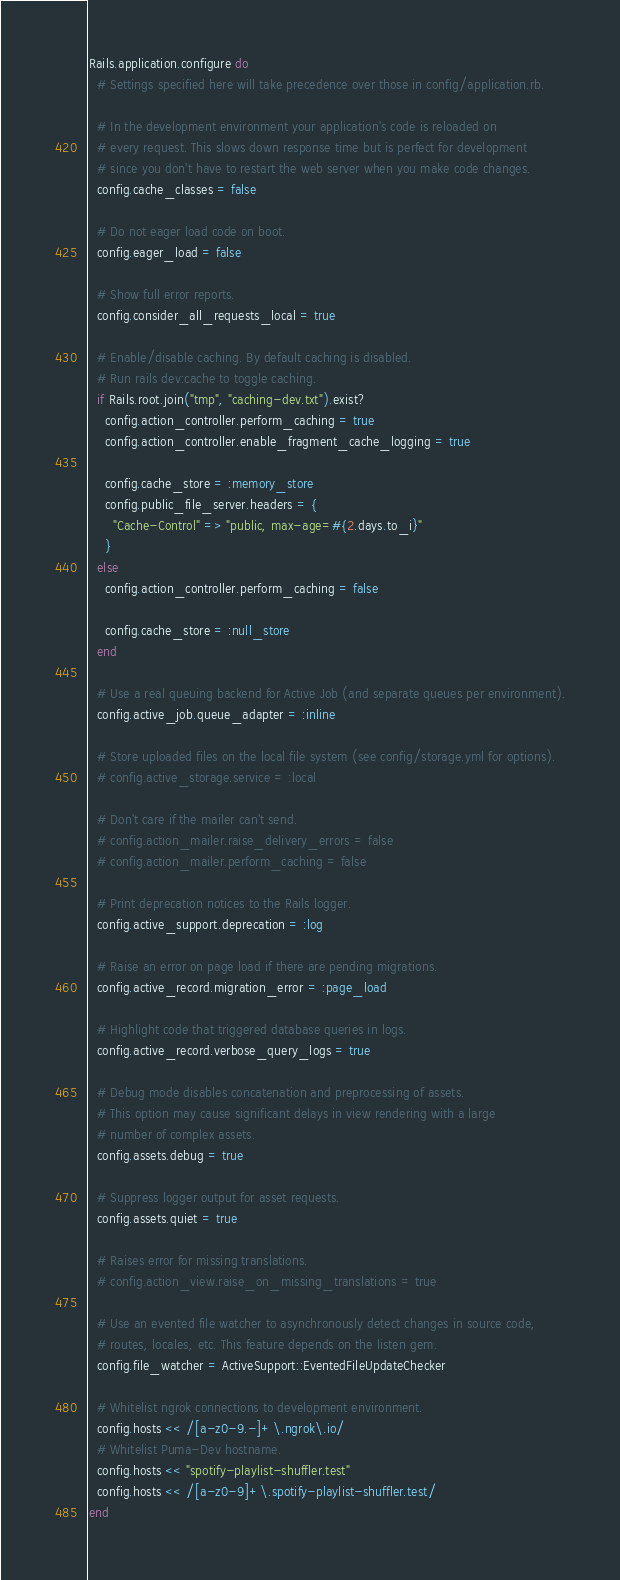<code> <loc_0><loc_0><loc_500><loc_500><_Ruby_>Rails.application.configure do
  # Settings specified here will take precedence over those in config/application.rb.

  # In the development environment your application's code is reloaded on
  # every request. This slows down response time but is perfect for development
  # since you don't have to restart the web server when you make code changes.
  config.cache_classes = false

  # Do not eager load code on boot.
  config.eager_load = false

  # Show full error reports.
  config.consider_all_requests_local = true

  # Enable/disable caching. By default caching is disabled.
  # Run rails dev:cache to toggle caching.
  if Rails.root.join("tmp", "caching-dev.txt").exist?
    config.action_controller.perform_caching = true
    config.action_controller.enable_fragment_cache_logging = true

    config.cache_store = :memory_store
    config.public_file_server.headers = {
      "Cache-Control" => "public, max-age=#{2.days.to_i}"
    }
  else
    config.action_controller.perform_caching = false

    config.cache_store = :null_store
  end

  # Use a real queuing backend for Active Job (and separate queues per environment).
  config.active_job.queue_adapter = :inline

  # Store uploaded files on the local file system (see config/storage.yml for options).
  # config.active_storage.service = :local

  # Don't care if the mailer can't send.
  # config.action_mailer.raise_delivery_errors = false
  # config.action_mailer.perform_caching = false

  # Print deprecation notices to the Rails logger.
  config.active_support.deprecation = :log

  # Raise an error on page load if there are pending migrations.
  config.active_record.migration_error = :page_load

  # Highlight code that triggered database queries in logs.
  config.active_record.verbose_query_logs = true

  # Debug mode disables concatenation and preprocessing of assets.
  # This option may cause significant delays in view rendering with a large
  # number of complex assets.
  config.assets.debug = true

  # Suppress logger output for asset requests.
  config.assets.quiet = true

  # Raises error for missing translations.
  # config.action_view.raise_on_missing_translations = true

  # Use an evented file watcher to asynchronously detect changes in source code,
  # routes, locales, etc. This feature depends on the listen gem.
  config.file_watcher = ActiveSupport::EventedFileUpdateChecker

  # Whitelist ngrok connections to development environment.
  config.hosts << /[a-z0-9.-]+\.ngrok\.io/
  # Whitelist Puma-Dev hostname.
  config.hosts << "spotify-playlist-shuffler.test"
  config.hosts << /[a-z0-9]+\.spotify-playlist-shuffler.test/
end
</code> 